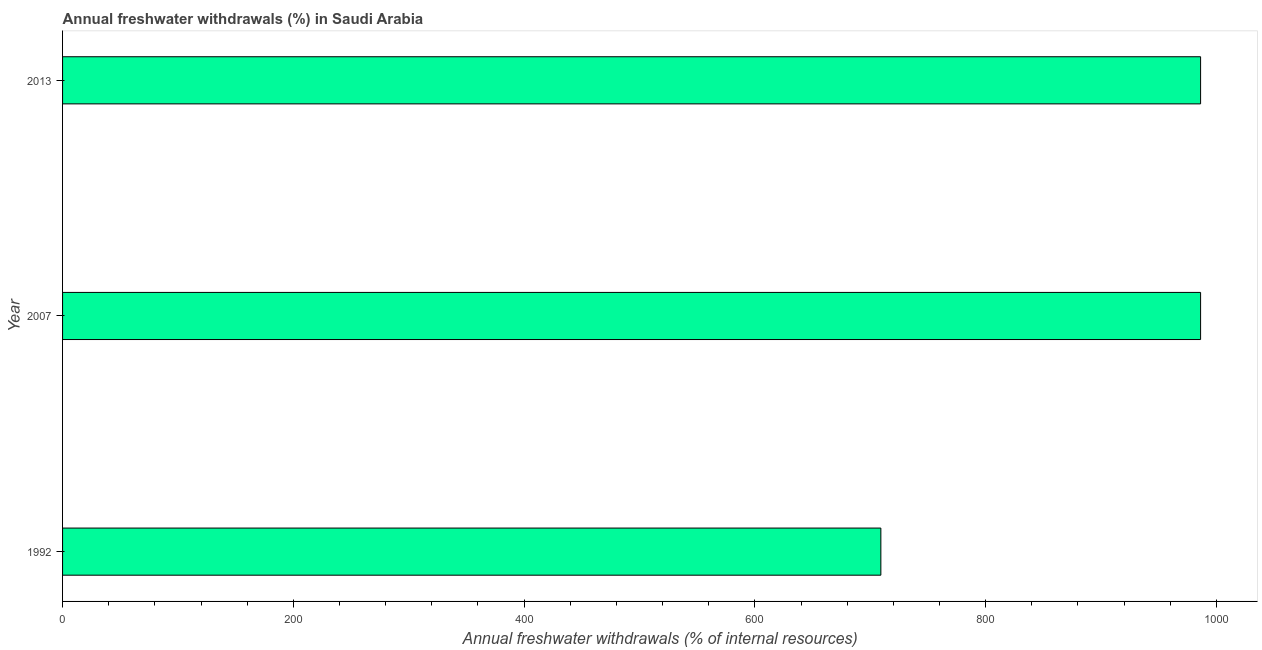Does the graph contain grids?
Give a very brief answer. No. What is the title of the graph?
Your answer should be very brief. Annual freshwater withdrawals (%) in Saudi Arabia. What is the label or title of the X-axis?
Provide a short and direct response. Annual freshwater withdrawals (% of internal resources). What is the annual freshwater withdrawals in 2007?
Provide a short and direct response. 986.25. Across all years, what is the maximum annual freshwater withdrawals?
Give a very brief answer. 986.25. Across all years, what is the minimum annual freshwater withdrawals?
Give a very brief answer. 709.17. What is the sum of the annual freshwater withdrawals?
Ensure brevity in your answer.  2681.67. What is the difference between the annual freshwater withdrawals in 1992 and 2013?
Your answer should be very brief. -277.08. What is the average annual freshwater withdrawals per year?
Ensure brevity in your answer.  893.89. What is the median annual freshwater withdrawals?
Provide a short and direct response. 986.25. Is the difference between the annual freshwater withdrawals in 1992 and 2013 greater than the difference between any two years?
Your response must be concise. Yes. Is the sum of the annual freshwater withdrawals in 1992 and 2013 greater than the maximum annual freshwater withdrawals across all years?
Offer a terse response. Yes. What is the difference between the highest and the lowest annual freshwater withdrawals?
Provide a succinct answer. 277.08. What is the difference between two consecutive major ticks on the X-axis?
Offer a very short reply. 200. What is the Annual freshwater withdrawals (% of internal resources) of 1992?
Provide a succinct answer. 709.17. What is the Annual freshwater withdrawals (% of internal resources) of 2007?
Give a very brief answer. 986.25. What is the Annual freshwater withdrawals (% of internal resources) in 2013?
Ensure brevity in your answer.  986.25. What is the difference between the Annual freshwater withdrawals (% of internal resources) in 1992 and 2007?
Provide a short and direct response. -277.08. What is the difference between the Annual freshwater withdrawals (% of internal resources) in 1992 and 2013?
Give a very brief answer. -277.08. What is the ratio of the Annual freshwater withdrawals (% of internal resources) in 1992 to that in 2007?
Provide a short and direct response. 0.72. What is the ratio of the Annual freshwater withdrawals (% of internal resources) in 1992 to that in 2013?
Offer a very short reply. 0.72. What is the ratio of the Annual freshwater withdrawals (% of internal resources) in 2007 to that in 2013?
Give a very brief answer. 1. 